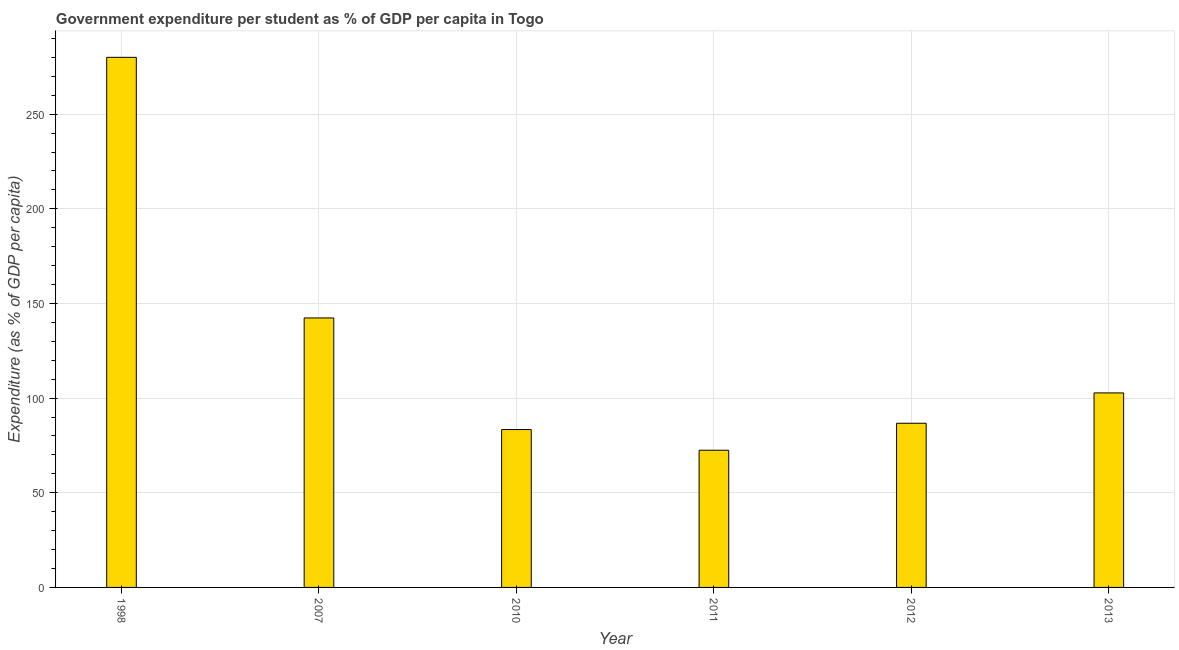Does the graph contain any zero values?
Your answer should be compact. No. Does the graph contain grids?
Offer a terse response. Yes. What is the title of the graph?
Your answer should be compact. Government expenditure per student as % of GDP per capita in Togo. What is the label or title of the X-axis?
Your response must be concise. Year. What is the label or title of the Y-axis?
Make the answer very short. Expenditure (as % of GDP per capita). What is the government expenditure per student in 2007?
Offer a very short reply. 142.35. Across all years, what is the maximum government expenditure per student?
Your answer should be very brief. 280.02. Across all years, what is the minimum government expenditure per student?
Give a very brief answer. 72.47. In which year was the government expenditure per student maximum?
Your answer should be very brief. 1998. In which year was the government expenditure per student minimum?
Keep it short and to the point. 2011. What is the sum of the government expenditure per student?
Provide a short and direct response. 767.71. What is the difference between the government expenditure per student in 2010 and 2012?
Offer a very short reply. -3.33. What is the average government expenditure per student per year?
Provide a succinct answer. 127.95. What is the median government expenditure per student?
Ensure brevity in your answer.  94.74. In how many years, is the government expenditure per student greater than 110 %?
Give a very brief answer. 2. What is the ratio of the government expenditure per student in 1998 to that in 2010?
Ensure brevity in your answer.  3.36. Is the government expenditure per student in 1998 less than that in 2013?
Your answer should be compact. No. What is the difference between the highest and the second highest government expenditure per student?
Give a very brief answer. 137.67. What is the difference between the highest and the lowest government expenditure per student?
Give a very brief answer. 207.55. In how many years, is the government expenditure per student greater than the average government expenditure per student taken over all years?
Provide a succinct answer. 2. How many years are there in the graph?
Ensure brevity in your answer.  6. Are the values on the major ticks of Y-axis written in scientific E-notation?
Ensure brevity in your answer.  No. What is the Expenditure (as % of GDP per capita) in 1998?
Offer a very short reply. 280.02. What is the Expenditure (as % of GDP per capita) in 2007?
Ensure brevity in your answer.  142.35. What is the Expenditure (as % of GDP per capita) of 2010?
Provide a short and direct response. 83.4. What is the Expenditure (as % of GDP per capita) of 2011?
Provide a succinct answer. 72.47. What is the Expenditure (as % of GDP per capita) of 2012?
Give a very brief answer. 86.72. What is the Expenditure (as % of GDP per capita) in 2013?
Keep it short and to the point. 102.75. What is the difference between the Expenditure (as % of GDP per capita) in 1998 and 2007?
Ensure brevity in your answer.  137.67. What is the difference between the Expenditure (as % of GDP per capita) in 1998 and 2010?
Provide a short and direct response. 196.62. What is the difference between the Expenditure (as % of GDP per capita) in 1998 and 2011?
Your answer should be very brief. 207.55. What is the difference between the Expenditure (as % of GDP per capita) in 1998 and 2012?
Your answer should be very brief. 193.3. What is the difference between the Expenditure (as % of GDP per capita) in 1998 and 2013?
Ensure brevity in your answer.  177.27. What is the difference between the Expenditure (as % of GDP per capita) in 2007 and 2010?
Offer a very short reply. 58.95. What is the difference between the Expenditure (as % of GDP per capita) in 2007 and 2011?
Offer a very short reply. 69.88. What is the difference between the Expenditure (as % of GDP per capita) in 2007 and 2012?
Your answer should be compact. 55.63. What is the difference between the Expenditure (as % of GDP per capita) in 2007 and 2013?
Provide a short and direct response. 39.6. What is the difference between the Expenditure (as % of GDP per capita) in 2010 and 2011?
Provide a short and direct response. 10.93. What is the difference between the Expenditure (as % of GDP per capita) in 2010 and 2012?
Ensure brevity in your answer.  -3.33. What is the difference between the Expenditure (as % of GDP per capita) in 2010 and 2013?
Your response must be concise. -19.35. What is the difference between the Expenditure (as % of GDP per capita) in 2011 and 2012?
Give a very brief answer. -14.26. What is the difference between the Expenditure (as % of GDP per capita) in 2011 and 2013?
Offer a very short reply. -30.28. What is the difference between the Expenditure (as % of GDP per capita) in 2012 and 2013?
Keep it short and to the point. -16.03. What is the ratio of the Expenditure (as % of GDP per capita) in 1998 to that in 2007?
Give a very brief answer. 1.97. What is the ratio of the Expenditure (as % of GDP per capita) in 1998 to that in 2010?
Your response must be concise. 3.36. What is the ratio of the Expenditure (as % of GDP per capita) in 1998 to that in 2011?
Provide a succinct answer. 3.86. What is the ratio of the Expenditure (as % of GDP per capita) in 1998 to that in 2012?
Make the answer very short. 3.23. What is the ratio of the Expenditure (as % of GDP per capita) in 1998 to that in 2013?
Your answer should be very brief. 2.73. What is the ratio of the Expenditure (as % of GDP per capita) in 2007 to that in 2010?
Ensure brevity in your answer.  1.71. What is the ratio of the Expenditure (as % of GDP per capita) in 2007 to that in 2011?
Provide a short and direct response. 1.96. What is the ratio of the Expenditure (as % of GDP per capita) in 2007 to that in 2012?
Give a very brief answer. 1.64. What is the ratio of the Expenditure (as % of GDP per capita) in 2007 to that in 2013?
Your answer should be very brief. 1.39. What is the ratio of the Expenditure (as % of GDP per capita) in 2010 to that in 2011?
Keep it short and to the point. 1.15. What is the ratio of the Expenditure (as % of GDP per capita) in 2010 to that in 2012?
Keep it short and to the point. 0.96. What is the ratio of the Expenditure (as % of GDP per capita) in 2010 to that in 2013?
Keep it short and to the point. 0.81. What is the ratio of the Expenditure (as % of GDP per capita) in 2011 to that in 2012?
Provide a short and direct response. 0.84. What is the ratio of the Expenditure (as % of GDP per capita) in 2011 to that in 2013?
Your response must be concise. 0.7. What is the ratio of the Expenditure (as % of GDP per capita) in 2012 to that in 2013?
Ensure brevity in your answer.  0.84. 